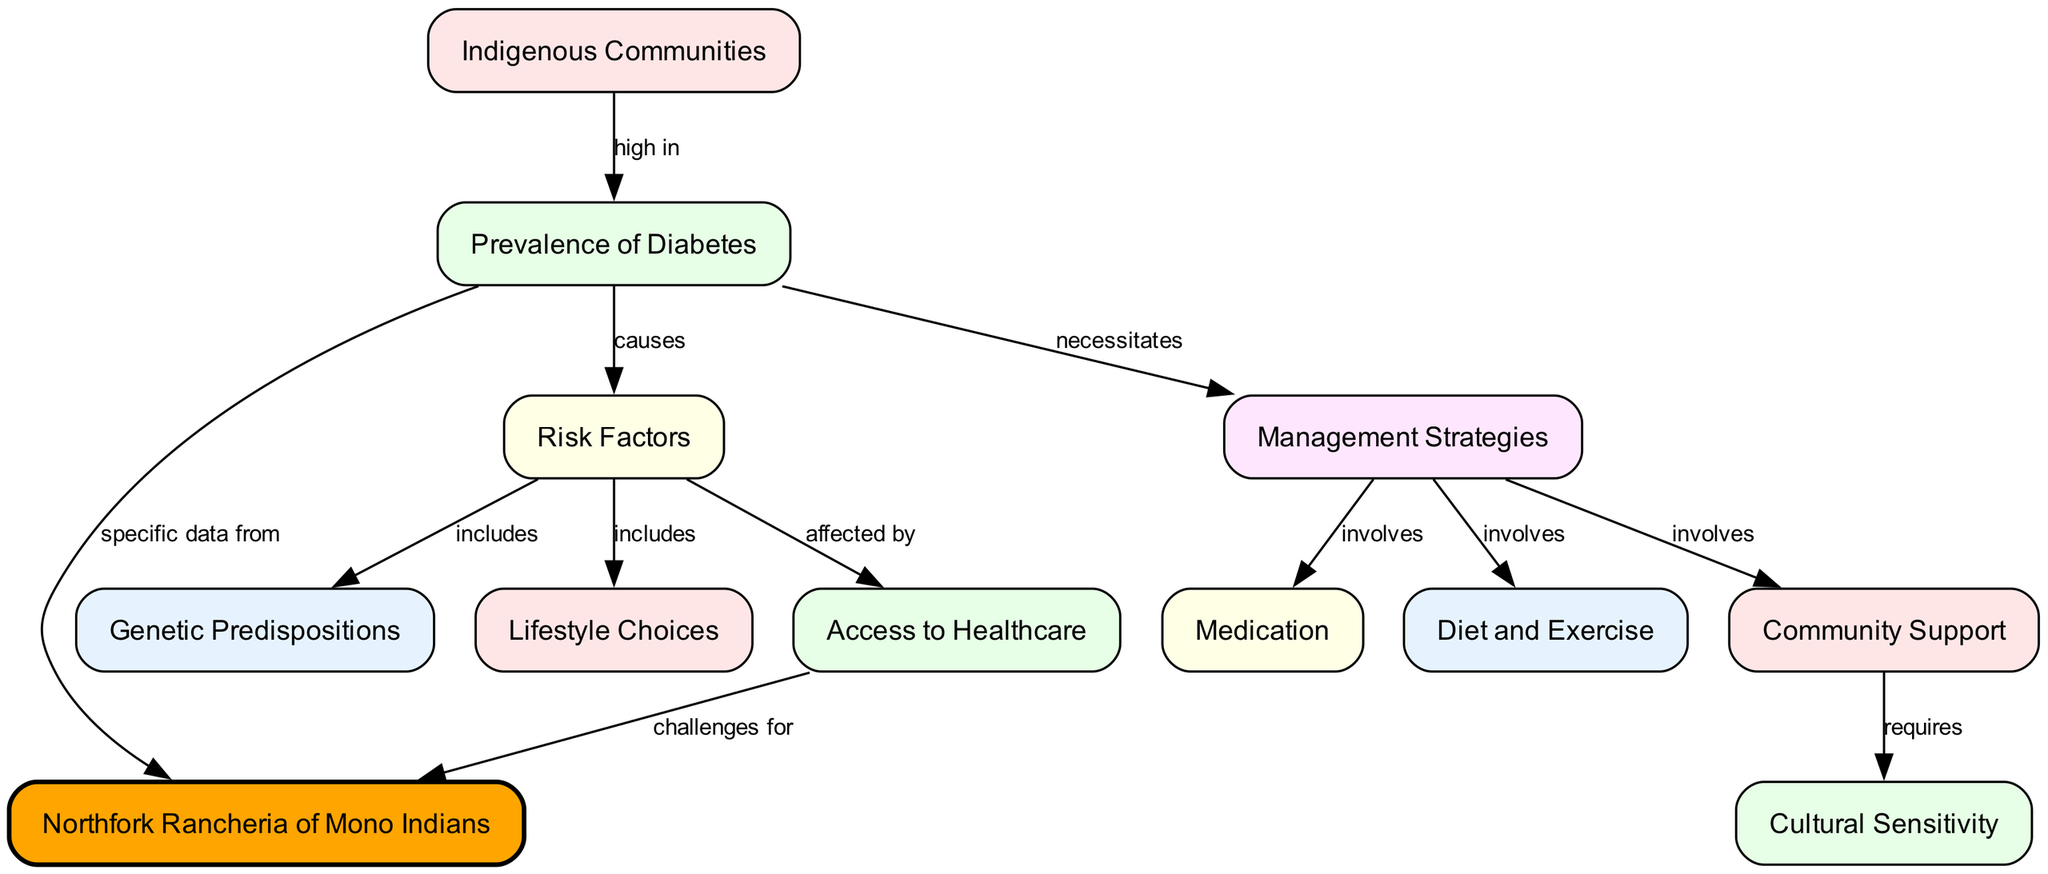What is the main topic represented in the diagram? The main topic is about the "Prevalence and Management of Diabetes" as it addresses the issues related to diabetes within Indigenous Communities, specifically highlighting the Northfork Rancheria of Mono Indians.
Answer: Prevalence and Management of Diabetes How many nodes are present in the diagram? By counting the distinct elements (nodes) listed, there are a total of 12 nodes representing different aspects related to diabetes.
Answer: 12 What does the "Risk Factors" node cause? The "Risk Factors" node leads to the "Prevalence of Diabetes" node and indicates that these risk factors are the causes of diabetes prevalence.
Answer: Prevalence of Diabetes Which node is directly connected to the "Northfork Rancheria of Mono Indians"? The "Northfork Rancheria of Mono Indians" is directly connected to the "Prevalence of Diabetes" node, as it provides specific data regarding diabetes prevalence in that community.
Answer: Prevalence of Diabetes What three management strategies are involved in managing diabetes? The "Management Strategies" node involves three key components, which are Medication, Diet and Exercise, and Community Support, indicating the approaches to managing diabetes.
Answer: Medication, Diet and Exercise, Community Support How are "Lifestyle Choices" categorized in relation to "Risk Factors"? "Lifestyle Choices" are categorized as a component of the "Risk Factors," suggesting they are one of the influences contributing to the prevalence of diabetes.
Answer: Included What does "Community Support" require for effective diabetes management? The "Community Support" node leads to "Cultural Sensitivity," implying that effective community support in managing diabetes necessitates an understanding and respect for the cultural context of the Indigenous Communities.
Answer: Cultural Sensitivity What is the relationship between "Access to Healthcare" and "Northfork Rancheria of Mono Indians"? "Access to Healthcare" is described as being affected by risk factors, including direct challenges faced by the Northfork Rancheria of Mono Indians in obtaining necessary healthcare services.
Answer: Challenges for Northfork Rancheria of Mono Indians What color represents the "Northfork Rancheria of Mono Indians" node in the diagram? The "Northfork Rancheria of Mono Indians" is highlighted with the color orange, indicating its importance in the context of the diagram compared to other nodes.
Answer: Orange 